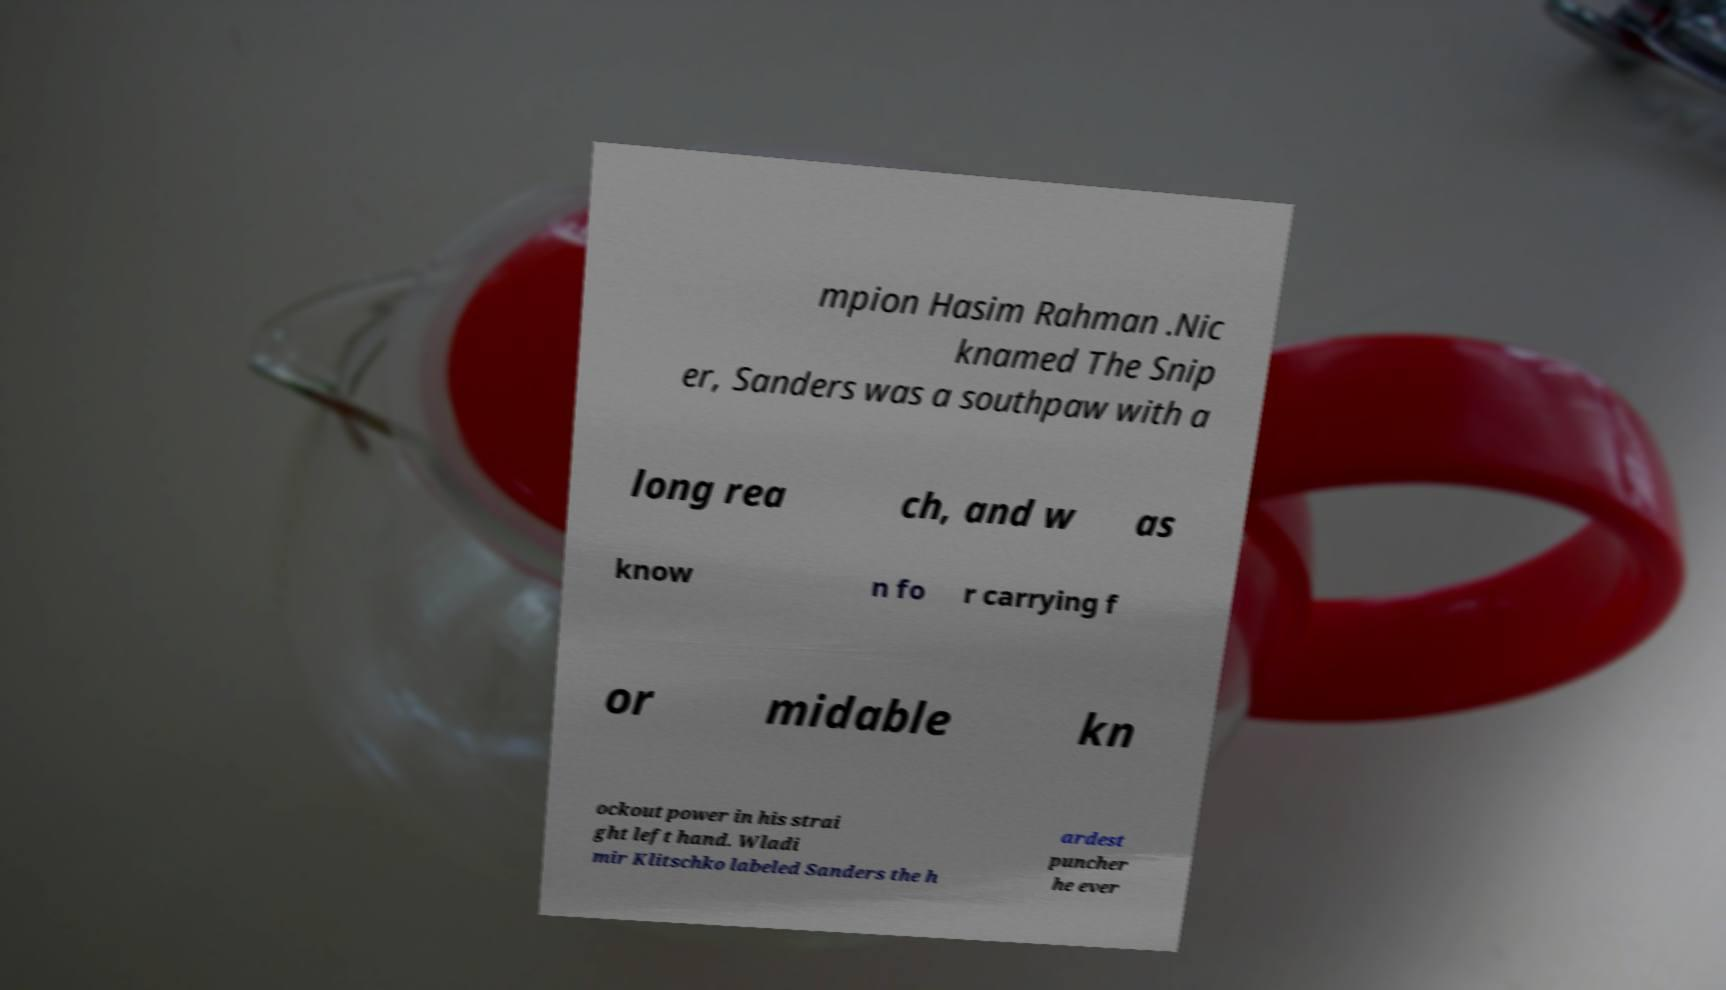Could you extract and type out the text from this image? mpion Hasim Rahman .Nic knamed The Snip er, Sanders was a southpaw with a long rea ch, and w as know n fo r carrying f or midable kn ockout power in his strai ght left hand. Wladi mir Klitschko labeled Sanders the h ardest puncher he ever 